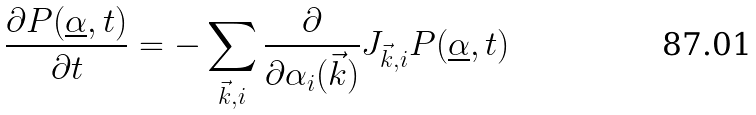<formula> <loc_0><loc_0><loc_500><loc_500>\frac { \partial P ( \underline { \alpha } , t ) } { \partial t } = - \sum _ { \vec { k } , i } \frac { \partial } { \partial \alpha _ { i } ( \vec { k } ) } J _ { \vec { k } , i } P ( \underline { \alpha } , t )</formula> 